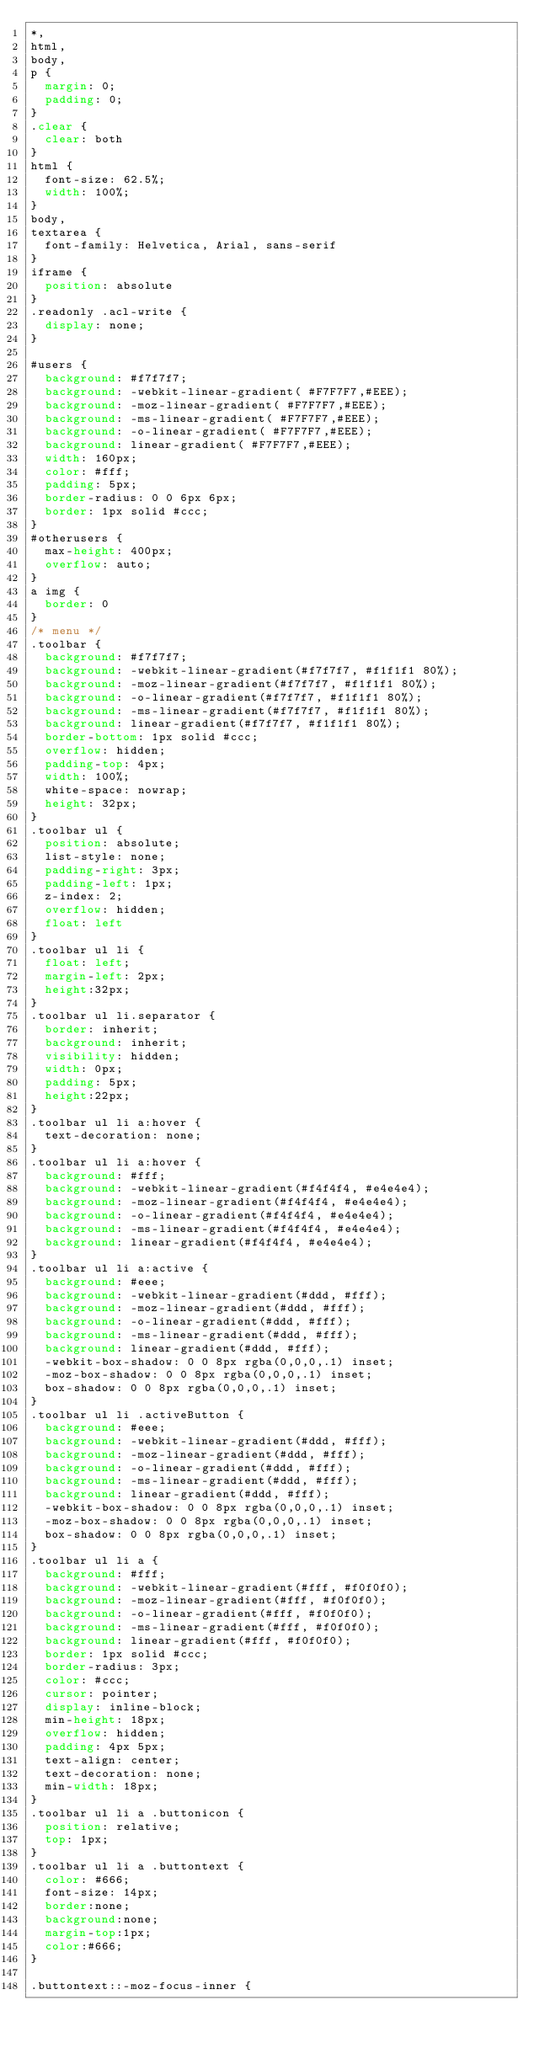<code> <loc_0><loc_0><loc_500><loc_500><_CSS_>*,
html,
body,
p {
  margin: 0;
  padding: 0;
}
.clear {
  clear: both
}
html {
  font-size: 62.5%;
  width: 100%;
}
body,
textarea {
  font-family: Helvetica, Arial, sans-serif
}
iframe {
  position: absolute
}
.readonly .acl-write {
  display: none;
}

#users {
  background: #f7f7f7;
  background: -webkit-linear-gradient( #F7F7F7,#EEE);
  background: -moz-linear-gradient( #F7F7F7,#EEE);
  background: -ms-linear-gradient( #F7F7F7,#EEE);
  background: -o-linear-gradient( #F7F7F7,#EEE);
  background: linear-gradient( #F7F7F7,#EEE);
  width: 160px;
  color: #fff;
  padding: 5px;
  border-radius: 0 0 6px 6px;
  border: 1px solid #ccc;
}
#otherusers {
  max-height: 400px;
  overflow: auto;
}
a img {
  border: 0
}
/* menu */
.toolbar {
  background: #f7f7f7;
  background: -webkit-linear-gradient(#f7f7f7, #f1f1f1 80%);
  background: -moz-linear-gradient(#f7f7f7, #f1f1f1 80%);
  background: -o-linear-gradient(#f7f7f7, #f1f1f1 80%);
  background: -ms-linear-gradient(#f7f7f7, #f1f1f1 80%);
  background: linear-gradient(#f7f7f7, #f1f1f1 80%);
  border-bottom: 1px solid #ccc;
  overflow: hidden;
  padding-top: 4px;
  width: 100%;
  white-space: nowrap;
  height: 32px;
}
.toolbar ul {
  position: absolute;
  list-style: none;
  padding-right: 3px;
  padding-left: 1px;
  z-index: 2;
  overflow: hidden;
  float: left
}
.toolbar ul li {
  float: left;
  margin-left: 2px;
  height:32px;
}
.toolbar ul li.separator {
  border: inherit;
  background: inherit;
  visibility: hidden;
  width: 0px;
  padding: 5px;
  height:22px;
}
.toolbar ul li a:hover {
  text-decoration: none;
}
.toolbar ul li a:hover {
  background: #fff;
  background: -webkit-linear-gradient(#f4f4f4, #e4e4e4);
  background: -moz-linear-gradient(#f4f4f4, #e4e4e4);
  background: -o-linear-gradient(#f4f4f4, #e4e4e4);
  background: -ms-linear-gradient(#f4f4f4, #e4e4e4);
  background: linear-gradient(#f4f4f4, #e4e4e4);
}
.toolbar ul li a:active {
  background: #eee;
  background: -webkit-linear-gradient(#ddd, #fff);
  background: -moz-linear-gradient(#ddd, #fff);
  background: -o-linear-gradient(#ddd, #fff);
  background: -ms-linear-gradient(#ddd, #fff);
  background: linear-gradient(#ddd, #fff);
  -webkit-box-shadow: 0 0 8px rgba(0,0,0,.1) inset;
  -moz-box-shadow: 0 0 8px rgba(0,0,0,.1) inset;
  box-shadow: 0 0 8px rgba(0,0,0,.1) inset;
}
.toolbar ul li .activeButton {
  background: #eee;
  background: -webkit-linear-gradient(#ddd, #fff);
  background: -moz-linear-gradient(#ddd, #fff);
  background: -o-linear-gradient(#ddd, #fff);
  background: -ms-linear-gradient(#ddd, #fff);
  background: linear-gradient(#ddd, #fff);
  -webkit-box-shadow: 0 0 8px rgba(0,0,0,.1) inset;
  -moz-box-shadow: 0 0 8px rgba(0,0,0,.1) inset;
  box-shadow: 0 0 8px rgba(0,0,0,.1) inset;
}
.toolbar ul li a {
  background: #fff;
  background: -webkit-linear-gradient(#fff, #f0f0f0);
  background: -moz-linear-gradient(#fff, #f0f0f0);
  background: -o-linear-gradient(#fff, #f0f0f0);
  background: -ms-linear-gradient(#fff, #f0f0f0);
  background: linear-gradient(#fff, #f0f0f0);
  border: 1px solid #ccc;
  border-radius: 3px;
  color: #ccc;
  cursor: pointer;
  display: inline-block;
  min-height: 18px;
  overflow: hidden;
  padding: 4px 5px;
  text-align: center;
  text-decoration: none;
  min-width: 18px;
}
.toolbar ul li a .buttonicon {
  position: relative;
  top: 1px;
}
.toolbar ul li a .buttontext {
  color: #666;
  font-size: 14px;
  border:none;
  background:none;
  margin-top:1px;
  color:#666;
}

.buttontext::-moz-focus-inner {</code> 